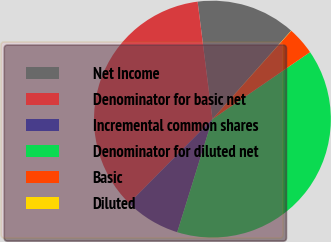<chart> <loc_0><loc_0><loc_500><loc_500><pie_chart><fcel>Net Income<fcel>Denominator for basic net<fcel>Incremental common shares<fcel>Denominator for diluted net<fcel>Basic<fcel>Diluted<nl><fcel>13.57%<fcel>35.58%<fcel>7.62%<fcel>39.37%<fcel>3.83%<fcel>0.03%<nl></chart> 